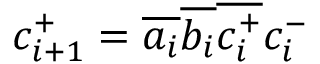Convert formula to latex. <formula><loc_0><loc_0><loc_500><loc_500>c _ { i + 1 } ^ { + } = { \overline { { a _ { i } } } } { \overline { { b _ { i } } } } { \overline { { c _ { i } ^ { + } } } } c _ { i } ^ { - }</formula> 